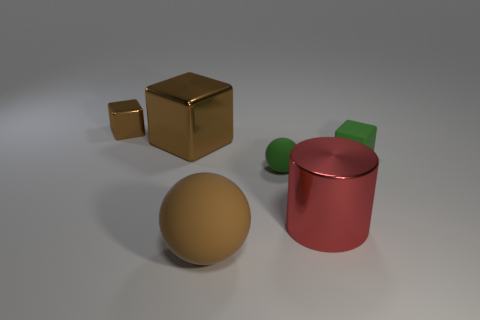What color is the tiny matte object that is to the left of the matte object that is to the right of the red shiny thing?
Ensure brevity in your answer.  Green. The other object that is the same shape as the large matte object is what color?
Provide a succinct answer. Green. How many metallic spheres have the same color as the large rubber sphere?
Offer a terse response. 0. Do the large metallic block and the tiny block that is on the left side of the tiny green rubber sphere have the same color?
Offer a very short reply. Yes. There is a small thing that is on the left side of the big red metallic cylinder and right of the big brown metallic block; what shape is it?
Provide a short and direct response. Sphere. What is the material of the brown object that is in front of the brown metallic cube in front of the block that is on the left side of the big brown metallic cube?
Offer a terse response. Rubber. Is the number of tiny green things behind the large brown rubber thing greater than the number of big brown things in front of the large cylinder?
Provide a succinct answer. Yes. How many tiny spheres have the same material as the small brown object?
Make the answer very short. 0. Does the thing that is in front of the big cylinder have the same shape as the tiny matte object to the left of the red object?
Make the answer very short. Yes. There is a large metallic object behind the tiny green block; what is its color?
Keep it short and to the point. Brown. 